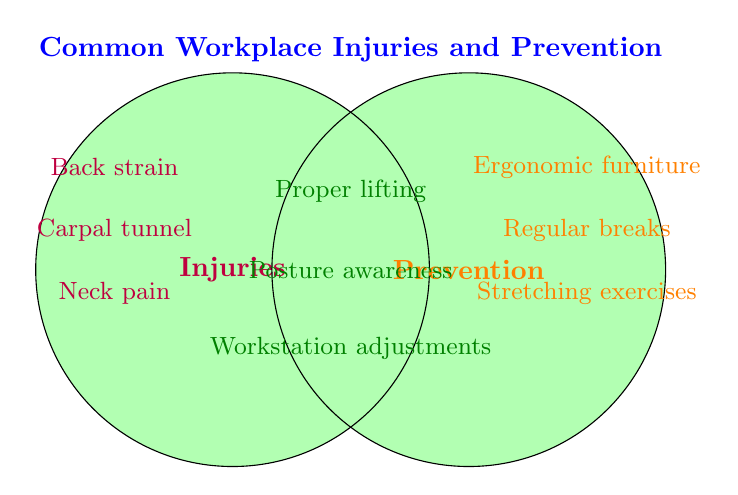What are the common injuries listed in the figure? The figure categorizes injuries separately, which are Back strain, Carpal tunnel, and Neck pain.
Answer: Back strain, Carpal tunnel, Neck pain What title is given to the figure? The title is placed at the top of the figure. It reads "Common Workplace Injuries and Prevention."
Answer: Common Workplace Injuries and Prevention Which prevention methods are listed on the right side? The figure lists prevention methods on the right side, separately colored. They are Ergonomic furniture, Regular breaks, and Stretching exercises.
Answer: Ergonomic furniture, Regular breaks, Stretching exercises Which elements fall under both categories of injuries and prevention? The elements in the intersection of the two circles belong to both categories. These are Proper lifting, Posture awareness, and Workstation adjustments.
Answer: Proper lifting, Posture awareness, Workstation adjustments How many items are listed under both categories (injuries and prevention)? The intersection of the two circles shows the items that fall under both categories. There are three such items.
Answer: 3 Compare the number of items listed under injuries and prevention methods. Which is greater? By counting the items: Injuries have three listed (Back strain, Carpal tunnel, Neck pain), and prevention methods have three listed (Ergonomic furniture, Regular breaks, Stretching exercises). Both categories have the same number of items.
Answer: Equal Which prevention methods are also related to preventing back strain according to the figure? The intersection of the circles combines the aspects that relate to both categories. Proper lifting, Posture awareness, and Workstation adjustments are relevant here.
Answer: Proper lifting, Posture awareness, Workstation adjustments Is "Regular breaks" considered both a prevention method and an injury, according to the figure? "Regular breaks" falls solely in the prevention methods circle, not in the intersection. Thus, it is not related to injuries but is purely a prevention method.
Answer: No Name one prevention method that is not associated with both injuries and prevention in the figure. Ergonomic furniture is listed solely in the prevention methods section and is not in the intersection of both categories.
Answer: Ergonomic furniture 